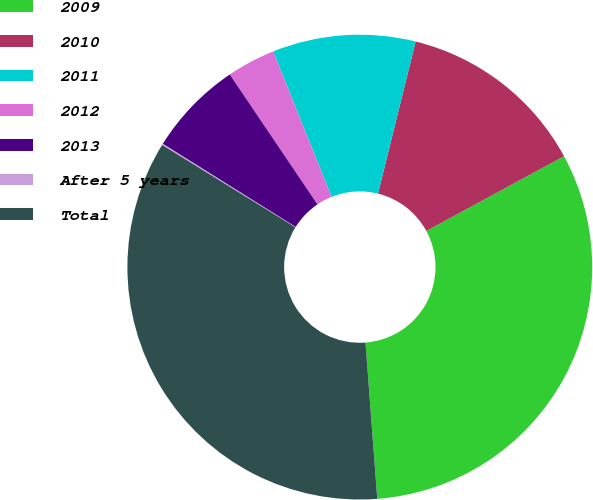Convert chart to OTSL. <chart><loc_0><loc_0><loc_500><loc_500><pie_chart><fcel>2009<fcel>2010<fcel>2011<fcel>2012<fcel>2013<fcel>After 5 years<fcel>Total<nl><fcel>31.72%<fcel>13.22%<fcel>9.94%<fcel>3.37%<fcel>6.65%<fcel>0.09%<fcel>35.0%<nl></chart> 